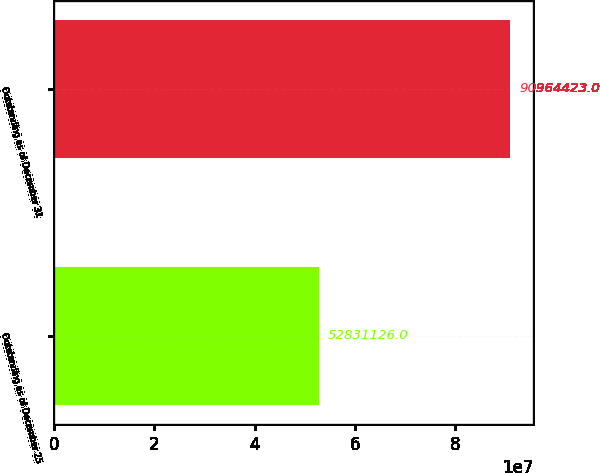Convert chart to OTSL. <chart><loc_0><loc_0><loc_500><loc_500><bar_chart><fcel>Outstanding as of December 25<fcel>Outstanding as of December 31<nl><fcel>5.28311e+07<fcel>9.09644e+07<nl></chart> 